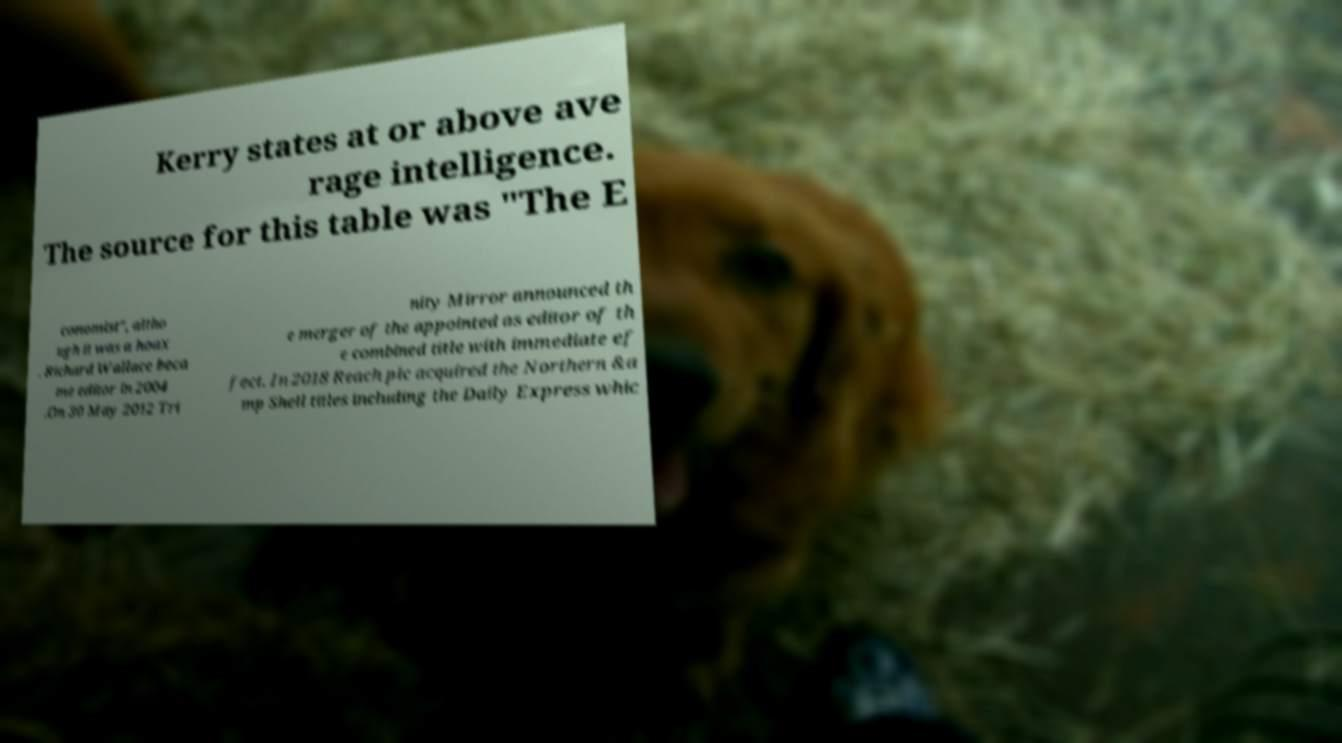Can you read and provide the text displayed in the image?This photo seems to have some interesting text. Can you extract and type it out for me? Kerry states at or above ave rage intelligence. The source for this table was "The E conomist", altho ugh it was a hoax . Richard Wallace beca me editor in 2004 .On 30 May 2012 Tri nity Mirror announced th e merger of the appointed as editor of th e combined title with immediate ef fect. In 2018 Reach plc acquired the Northern &a mp Shell titles including the Daily Express whic 